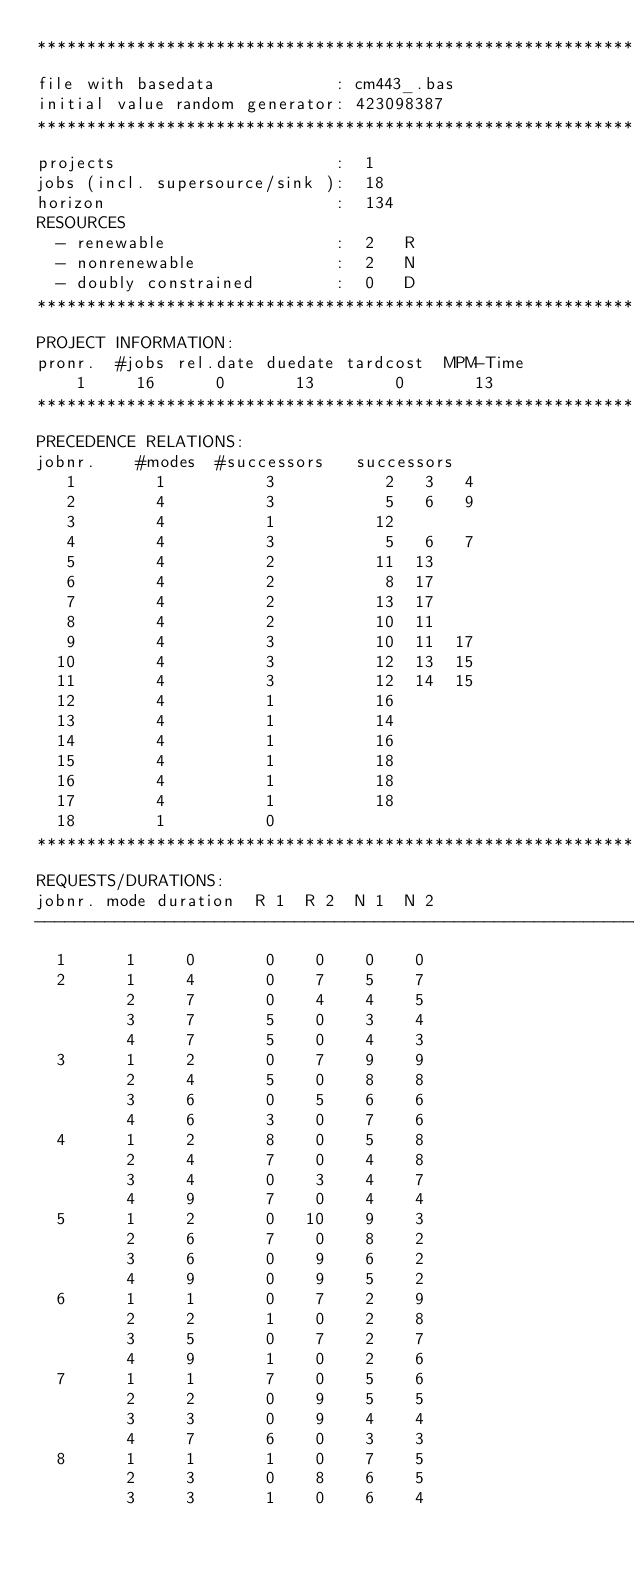Convert code to text. <code><loc_0><loc_0><loc_500><loc_500><_ObjectiveC_>************************************************************************
file with basedata            : cm443_.bas
initial value random generator: 423098387
************************************************************************
projects                      :  1
jobs (incl. supersource/sink ):  18
horizon                       :  134
RESOURCES
  - renewable                 :  2   R
  - nonrenewable              :  2   N
  - doubly constrained        :  0   D
************************************************************************
PROJECT INFORMATION:
pronr.  #jobs rel.date duedate tardcost  MPM-Time
    1     16      0       13        0       13
************************************************************************
PRECEDENCE RELATIONS:
jobnr.    #modes  #successors   successors
   1        1          3           2   3   4
   2        4          3           5   6   9
   3        4          1          12
   4        4          3           5   6   7
   5        4          2          11  13
   6        4          2           8  17
   7        4          2          13  17
   8        4          2          10  11
   9        4          3          10  11  17
  10        4          3          12  13  15
  11        4          3          12  14  15
  12        4          1          16
  13        4          1          14
  14        4          1          16
  15        4          1          18
  16        4          1          18
  17        4          1          18
  18        1          0        
************************************************************************
REQUESTS/DURATIONS:
jobnr. mode duration  R 1  R 2  N 1  N 2
------------------------------------------------------------------------
  1      1     0       0    0    0    0
  2      1     4       0    7    5    7
         2     7       0    4    4    5
         3     7       5    0    3    4
         4     7       5    0    4    3
  3      1     2       0    7    9    9
         2     4       5    0    8    8
         3     6       0    5    6    6
         4     6       3    0    7    6
  4      1     2       8    0    5    8
         2     4       7    0    4    8
         3     4       0    3    4    7
         4     9       7    0    4    4
  5      1     2       0   10    9    3
         2     6       7    0    8    2
         3     6       0    9    6    2
         4     9       0    9    5    2
  6      1     1       0    7    2    9
         2     2       1    0    2    8
         3     5       0    7    2    7
         4     9       1    0    2    6
  7      1     1       7    0    5    6
         2     2       0    9    5    5
         3     3       0    9    4    4
         4     7       6    0    3    3
  8      1     1       1    0    7    5
         2     3       0    8    6    5
         3     3       1    0    6    4</code> 